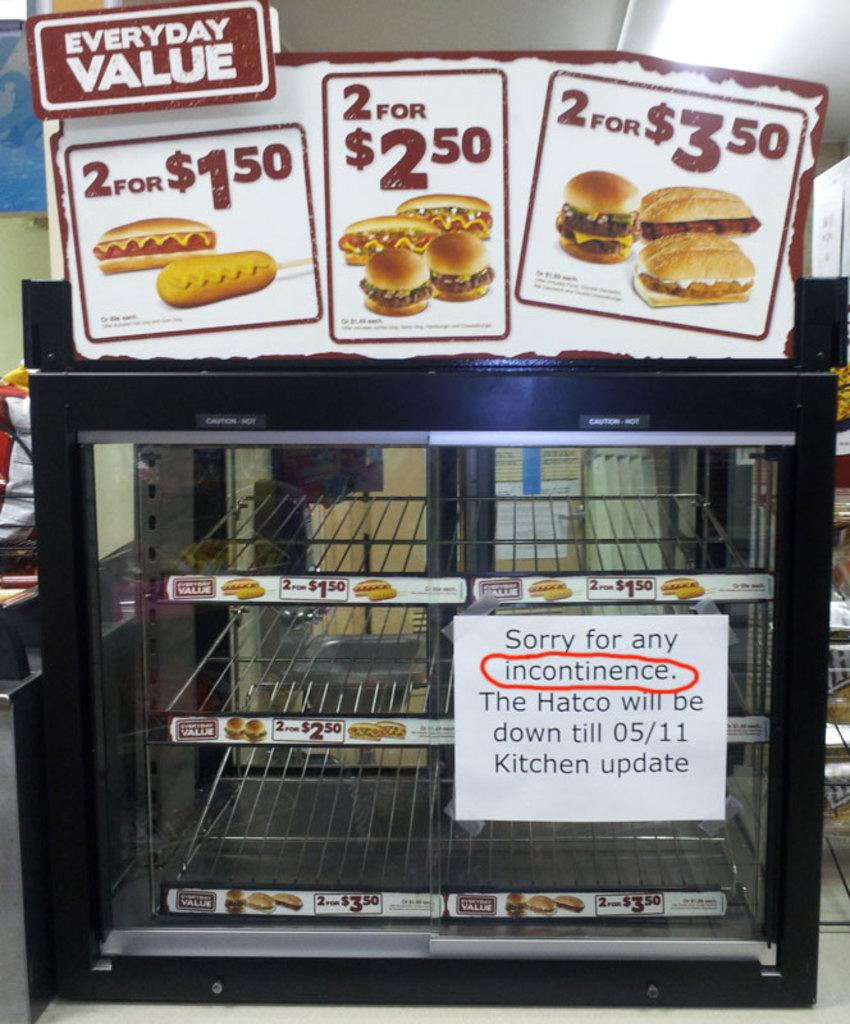<image>
Offer a succinct explanation of the picture presented. a series of advertisements with a 2 hot dog for 1.50 deal 